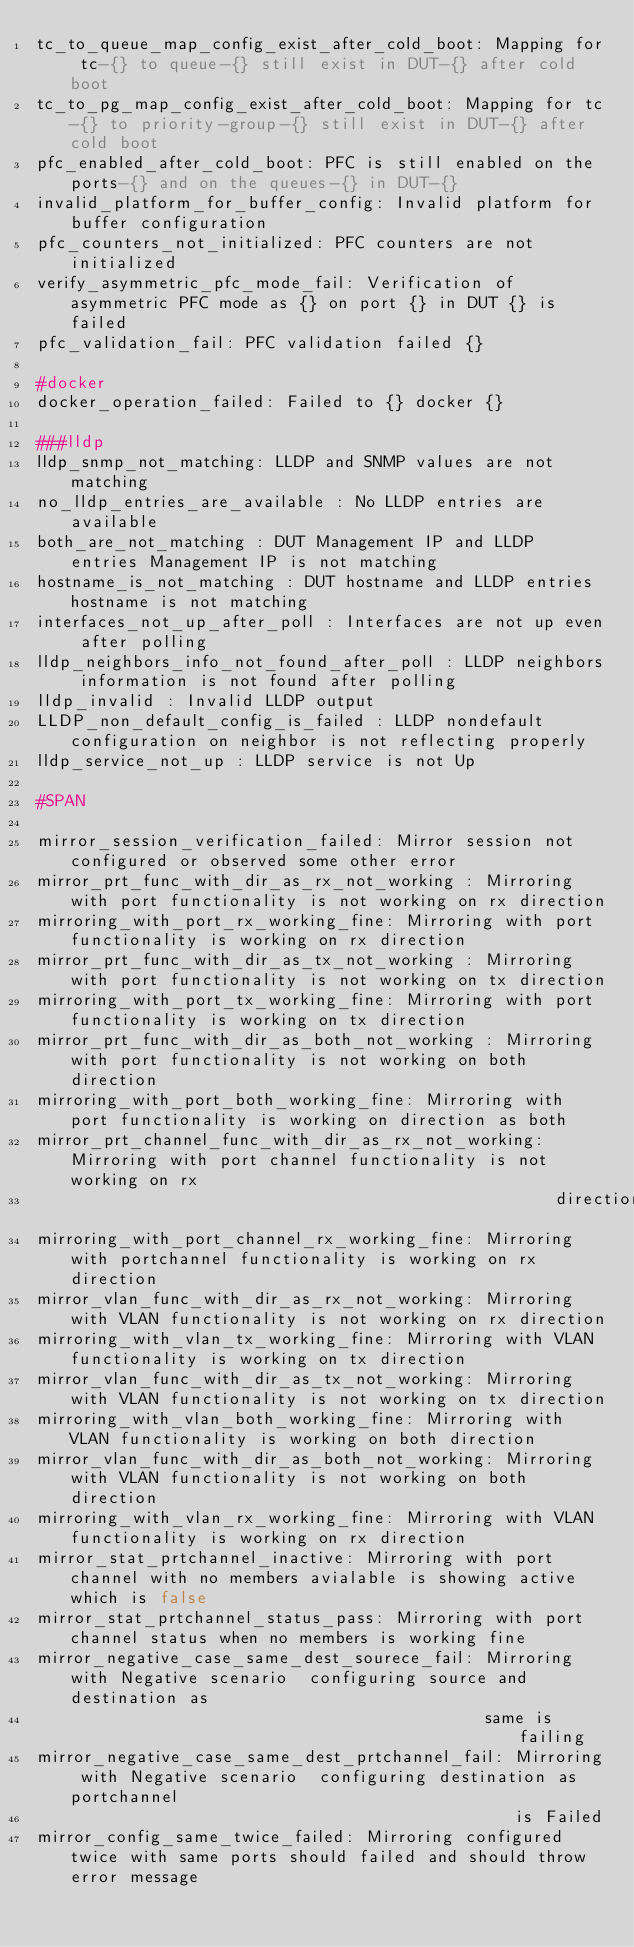<code> <loc_0><loc_0><loc_500><loc_500><_YAML_>tc_to_queue_map_config_exist_after_cold_boot: Mapping for tc-{} to queue-{} still exist in DUT-{} after cold boot
tc_to_pg_map_config_exist_after_cold_boot: Mapping for tc-{} to priority-group-{} still exist in DUT-{} after cold boot
pfc_enabled_after_cold_boot: PFC is still enabled on the ports-{} and on the queues-{} in DUT-{}
invalid_platform_for_buffer_config: Invalid platform for buffer configuration
pfc_counters_not_initialized: PFC counters are not initialized
verify_asymmetric_pfc_mode_fail: Verification of asymmetric PFC mode as {} on port {} in DUT {} is failed
pfc_validation_fail: PFC validation failed {}

#docker
docker_operation_failed: Failed to {} docker {}

###lldp
lldp_snmp_not_matching: LLDP and SNMP values are not matching
no_lldp_entries_are_available : No LLDP entries are available
both_are_not_matching : DUT Management IP and LLDP entries Management IP is not matching
hostname_is_not_matching : DUT hostname and LLDP entries hostname is not matching
interfaces_not_up_after_poll : Interfaces are not up even after polling
lldp_neighbors_info_not_found_after_poll : LLDP neighbors information is not found after polling
lldp_invalid : Invalid LLDP output
LLDP_non_default_config_is_failed : LLDP nondefault configuration on neighbor is not reflecting properly
lldp_service_not_up : LLDP service is not Up

#SPAN

mirror_session_verification_failed: Mirror session not configured or observed some other error
mirror_prt_func_with_dir_as_rx_not_working : Mirroring with port functionality is not working on rx direction
mirroring_with_port_rx_working_fine: Mirroring with port functionality is working on rx direction
mirror_prt_func_with_dir_as_tx_not_working : Mirroring with port functionality is not working on tx direction
mirroring_with_port_tx_working_fine: Mirroring with port functionality is working on tx direction
mirror_prt_func_with_dir_as_both_not_working : Mirroring with port functionality is not working on both direction
mirroring_with_port_both_working_fine: Mirroring with port functionality is working on direction as both
mirror_prt_channel_func_with_dir_as_rx_not_working: Mirroring with port channel functionality is not working on rx
                                                    direction
mirroring_with_port_channel_rx_working_fine: Mirroring with portchannel functionality is working on rx direction
mirror_vlan_func_with_dir_as_rx_not_working: Mirroring with VLAN functionality is not working on rx direction
mirroring_with_vlan_tx_working_fine: Mirroring with VLAN functionality is working on tx direction
mirror_vlan_func_with_dir_as_tx_not_working: Mirroring with VLAN functionality is not working on tx direction
mirroring_with_vlan_both_working_fine: Mirroring with VLAN functionality is working on both direction
mirror_vlan_func_with_dir_as_both_not_working: Mirroring with VLAN functionality is not working on both direction
mirroring_with_vlan_rx_working_fine: Mirroring with VLAN functionality is working on rx direction
mirror_stat_prtchannel_inactive: Mirroring with port channel with no members avialable is showing active which is false
mirror_stat_prtchannel_status_pass: Mirroring with port channel status when no members is working fine
mirror_negative_case_same_dest_sourece_fail: Mirroring with Negative scenario  configuring source and destination as
                                             same is failing
mirror_negative_case_same_dest_prtchannel_fail: Mirroring with Negative scenario  configuring destination as portchannel
                                                is Failed
mirror_config_same_twice_failed: Mirroring configured twice with same ports should failed and should throw error message</code> 